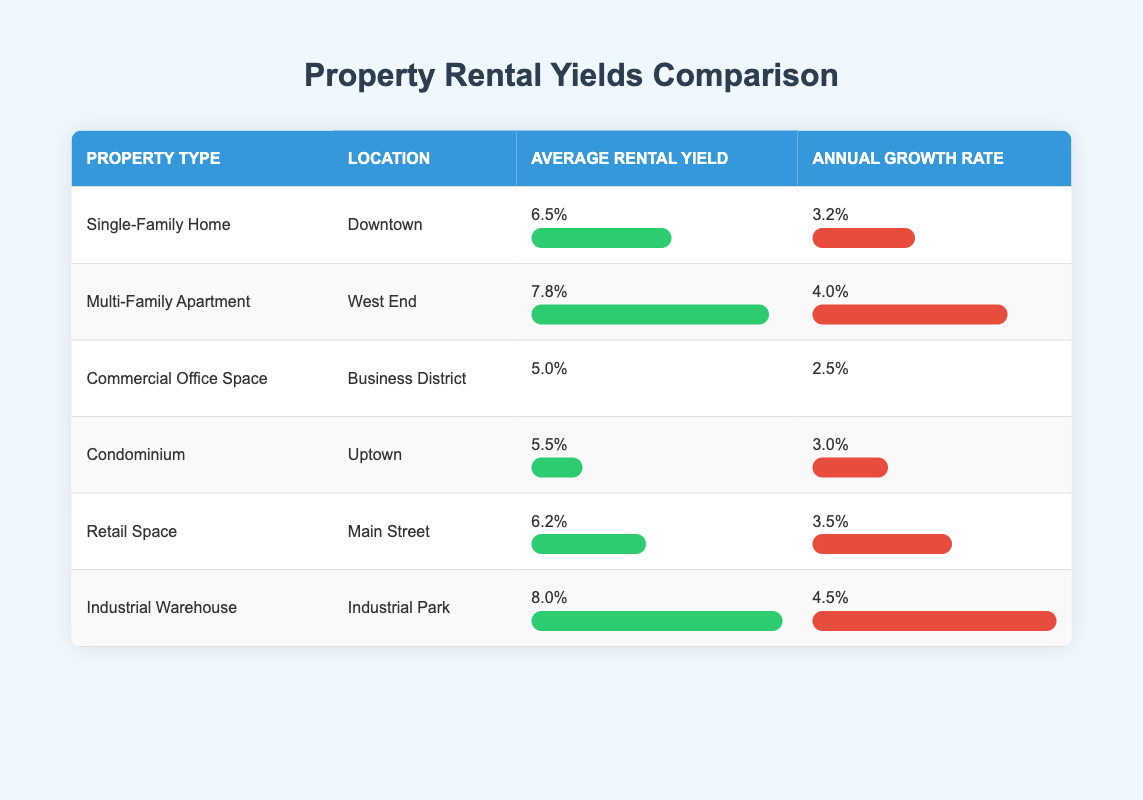What is the average rental yield for Single-Family Homes? The average rental yield for Single-Family Homes listed in the table is 6.5% as directly referenced from the relevant row.
Answer: 6.5% Which property type has the highest average rental yield? Examining the average rental yields, the Industrial Warehouse has the highest average rental yield of 8.0%, as seen in its designated row.
Answer: Industrial Warehouse Is the annual growth rate for Multi-Family Apartment higher than that of Commercial Office Space? Looking at the annual growth rates, the Multi-Family Apartment shows a rate of 4.0% and the Commercial Office Space has a rate of 2.5%. Since 4.0% is greater than 2.5%, the answer is yes.
Answer: Yes What is the total average rental yield for Commercial Office Space and Retail Space? The average rental yield for Commercial Office Space is 5.0% and for Retail Space is 6.2%. Adding these yields together gives us 5.0% + 6.2% = 11.2%.
Answer: 11.2% Which location has the lowest annual growth rate, and what is it? From the table, the Commercial Office Space located in the Business District has the lowest annual growth rate at 2.5%, as indicated within that row.
Answer: Business District, 2.5% If I wanted to invest, how many property types offer a rental yield greater than 7%? We can see from the table that only the Multi-Family Apartment with 7.8% and Industrial Warehouse with 8.0% exceed 7%. Thus, there are 2 property types that meet this criterion.
Answer: 2 What is the difference in the average rental yield between Industrial Warehouse and Condominium? The average rental yield for Industrial Warehouse is 8.0% and for Condominium it is 5.5%. The difference is calculated as 8.0% - 5.5% = 2.5%.
Answer: 2.5% Do all property types have an annual growth rate above 3%? Upon assessment, we see that the Commercial Office Space has an annual growth rate of 2.5%, which is below 3%. Thus, the answer is no.
Answer: No Which property type has the highest annual growth rate and what is the percentage? Looking through the data, the Industrial Warehouse shows the highest annual growth rate at 4.5%, as observed in its corresponding row.
Answer: Industrial Warehouse, 4.5% 